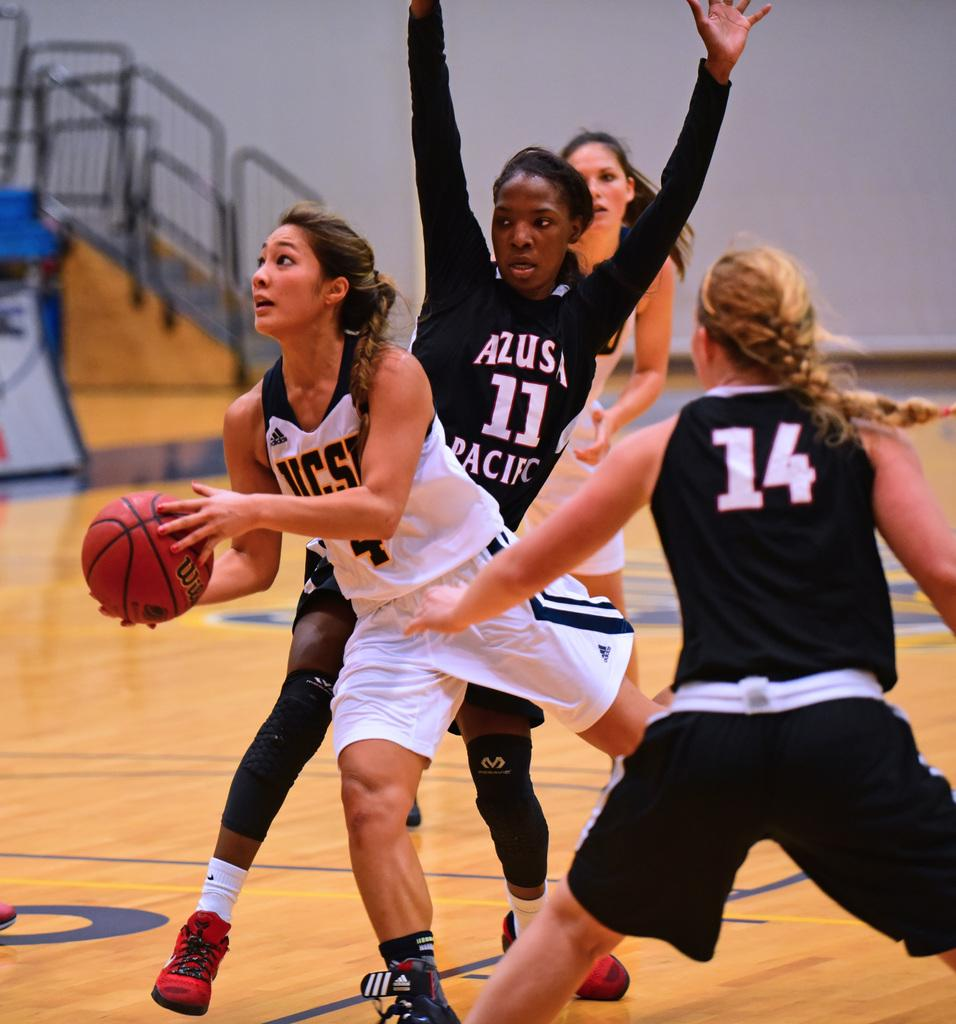<image>
Relay a brief, clear account of the picture shown. A girls basketball game with numbers 14 and 11 playing on the same team. 